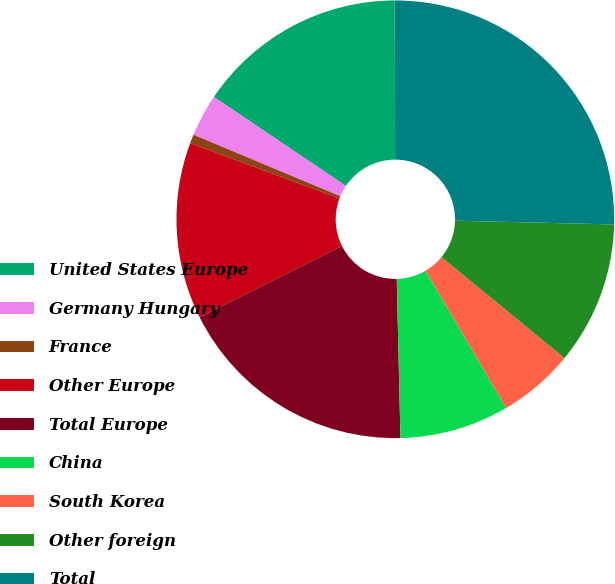<chart> <loc_0><loc_0><loc_500><loc_500><pie_chart><fcel>United States Europe<fcel>Germany Hungary<fcel>France<fcel>Other Europe<fcel>Total Europe<fcel>China<fcel>South Korea<fcel>Other foreign<fcel>Total<nl><fcel>15.51%<fcel>3.13%<fcel>0.65%<fcel>13.04%<fcel>17.99%<fcel>8.08%<fcel>5.61%<fcel>10.56%<fcel>25.42%<nl></chart> 